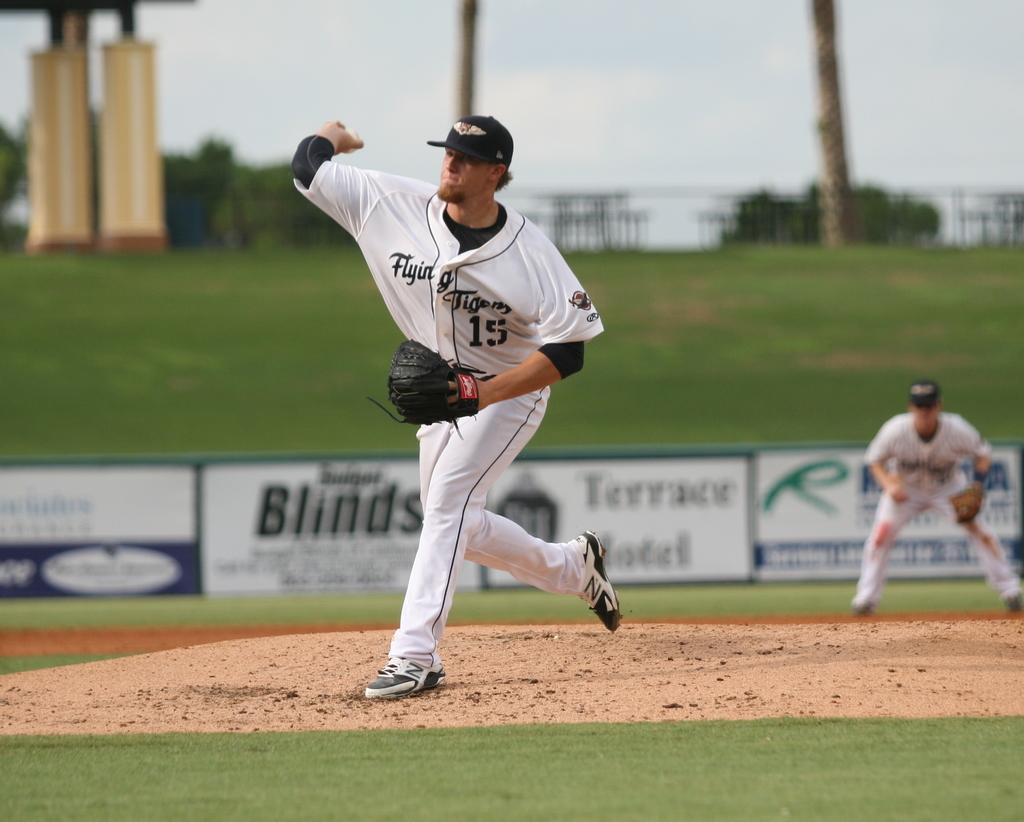Provide a one-sentence caption for the provided image. The pitcher, who is number 15, is about to pitch the baseball. 